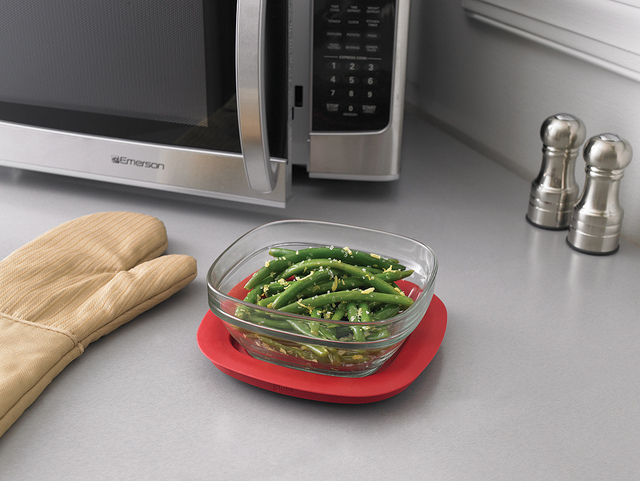How many green veggies are in the bowl?
Answer the question using a single word or phrase. 1 What is the bowl of green beans sitting on? Lid What is the red item under the bowl? Lid 